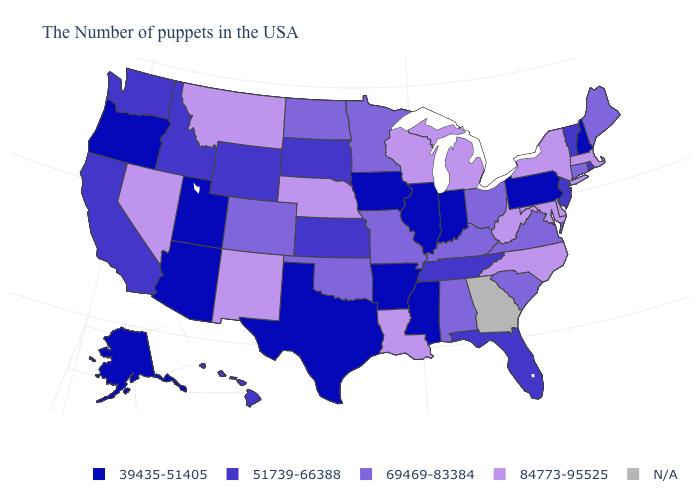Among the states that border Iowa , which have the highest value?
Concise answer only. Wisconsin, Nebraska. Is the legend a continuous bar?
Answer briefly. No. What is the value of Mississippi?
Keep it brief. 39435-51405. Which states have the lowest value in the South?
Keep it brief. Mississippi, Arkansas, Texas. Name the states that have a value in the range N/A?
Give a very brief answer. Georgia. Name the states that have a value in the range 69469-83384?
Be succinct. Maine, Connecticut, Virginia, South Carolina, Ohio, Kentucky, Alabama, Missouri, Minnesota, Oklahoma, North Dakota, Colorado. What is the value of Alaska?
Write a very short answer. 39435-51405. Which states hav the highest value in the Northeast?
Keep it brief. Massachusetts, New York. Name the states that have a value in the range 69469-83384?
Be succinct. Maine, Connecticut, Virginia, South Carolina, Ohio, Kentucky, Alabama, Missouri, Minnesota, Oklahoma, North Dakota, Colorado. What is the value of California?
Be succinct. 51739-66388. Is the legend a continuous bar?
Answer briefly. No. What is the highest value in states that border Tennessee?
Concise answer only. 84773-95525. Which states have the lowest value in the Northeast?
Be succinct. New Hampshire, Pennsylvania. 